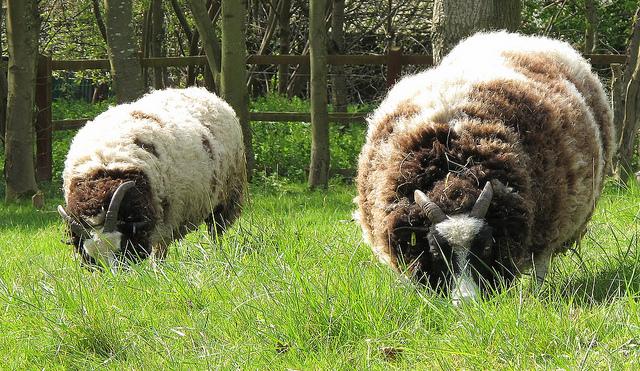Are these animals asleep or eating?
Give a very brief answer. Eating. Are they human?
Answer briefly. No. What animal is this?
Keep it brief. Sheep. 